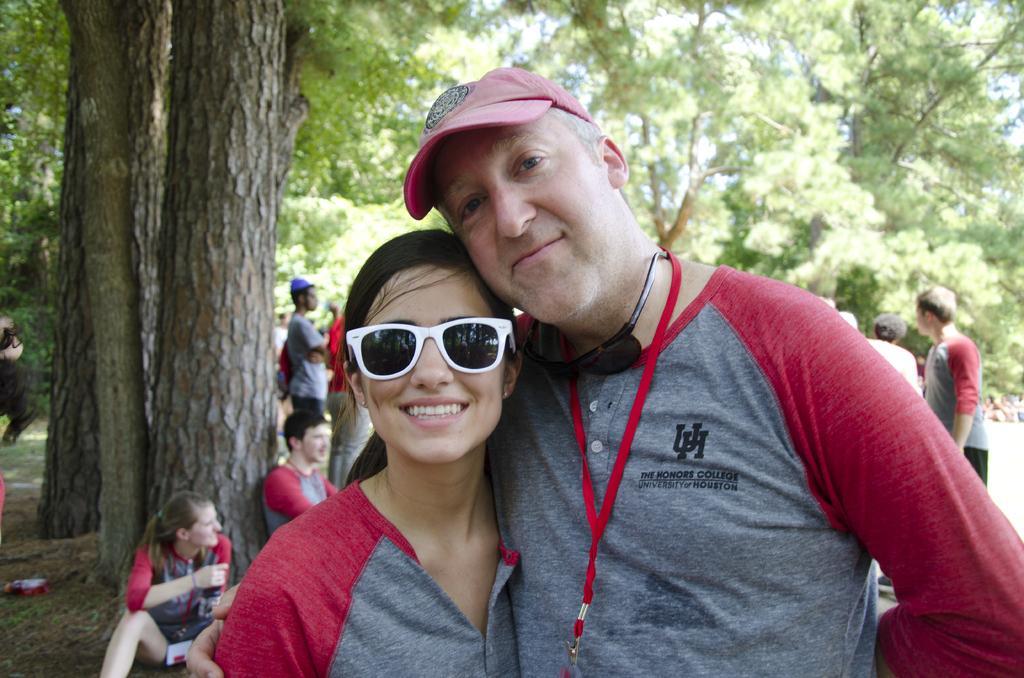Could you give a brief overview of what you see in this image? In this image we can see a man and woman wearing grey color T-shirts are standing on the ground and smiling. In the background, we can see a few more people and trees. 